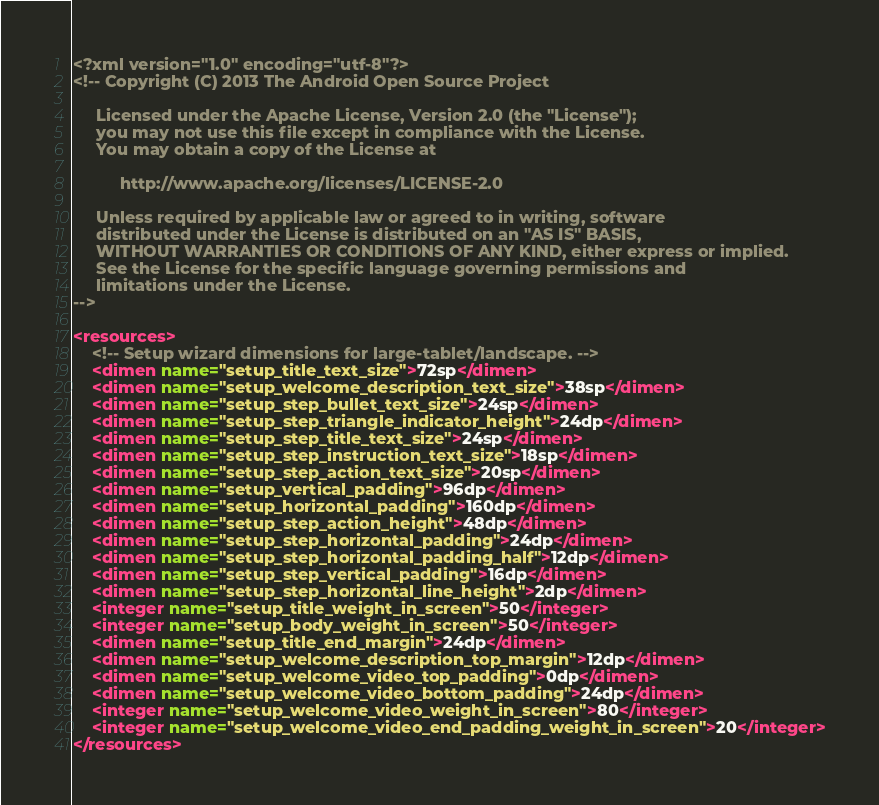<code> <loc_0><loc_0><loc_500><loc_500><_XML_><?xml version="1.0" encoding="utf-8"?>
<!-- Copyright (C) 2013 The Android Open Source Project

     Licensed under the Apache License, Version 2.0 (the "License");
     you may not use this file except in compliance with the License.
     You may obtain a copy of the License at

          http://www.apache.org/licenses/LICENSE-2.0

     Unless required by applicable law or agreed to in writing, software
     distributed under the License is distributed on an "AS IS" BASIS,
     WITHOUT WARRANTIES OR CONDITIONS OF ANY KIND, either express or implied.
     See the License for the specific language governing permissions and
     limitations under the License.
-->

<resources>
    <!-- Setup wizard dimensions for large-tablet/landscape. -->
    <dimen name="setup_title_text_size">72sp</dimen>
    <dimen name="setup_welcome_description_text_size">38sp</dimen>
    <dimen name="setup_step_bullet_text_size">24sp</dimen>
    <dimen name="setup_step_triangle_indicator_height">24dp</dimen>
    <dimen name="setup_step_title_text_size">24sp</dimen>
    <dimen name="setup_step_instruction_text_size">18sp</dimen>
    <dimen name="setup_step_action_text_size">20sp</dimen>
    <dimen name="setup_vertical_padding">96dp</dimen>
    <dimen name="setup_horizontal_padding">160dp</dimen>
    <dimen name="setup_step_action_height">48dp</dimen>
    <dimen name="setup_step_horizontal_padding">24dp</dimen>
    <dimen name="setup_step_horizontal_padding_half">12dp</dimen>
    <dimen name="setup_step_vertical_padding">16dp</dimen>
    <dimen name="setup_step_horizontal_line_height">2dp</dimen>
    <integer name="setup_title_weight_in_screen">50</integer>
    <integer name="setup_body_weight_in_screen">50</integer>
    <dimen name="setup_title_end_margin">24dp</dimen>
    <dimen name="setup_welcome_description_top_margin">12dp</dimen>
    <dimen name="setup_welcome_video_top_padding">0dp</dimen>
    <dimen name="setup_welcome_video_bottom_padding">24dp</dimen>
    <integer name="setup_welcome_video_weight_in_screen">80</integer>
    <integer name="setup_welcome_video_end_padding_weight_in_screen">20</integer>
</resources>
</code> 